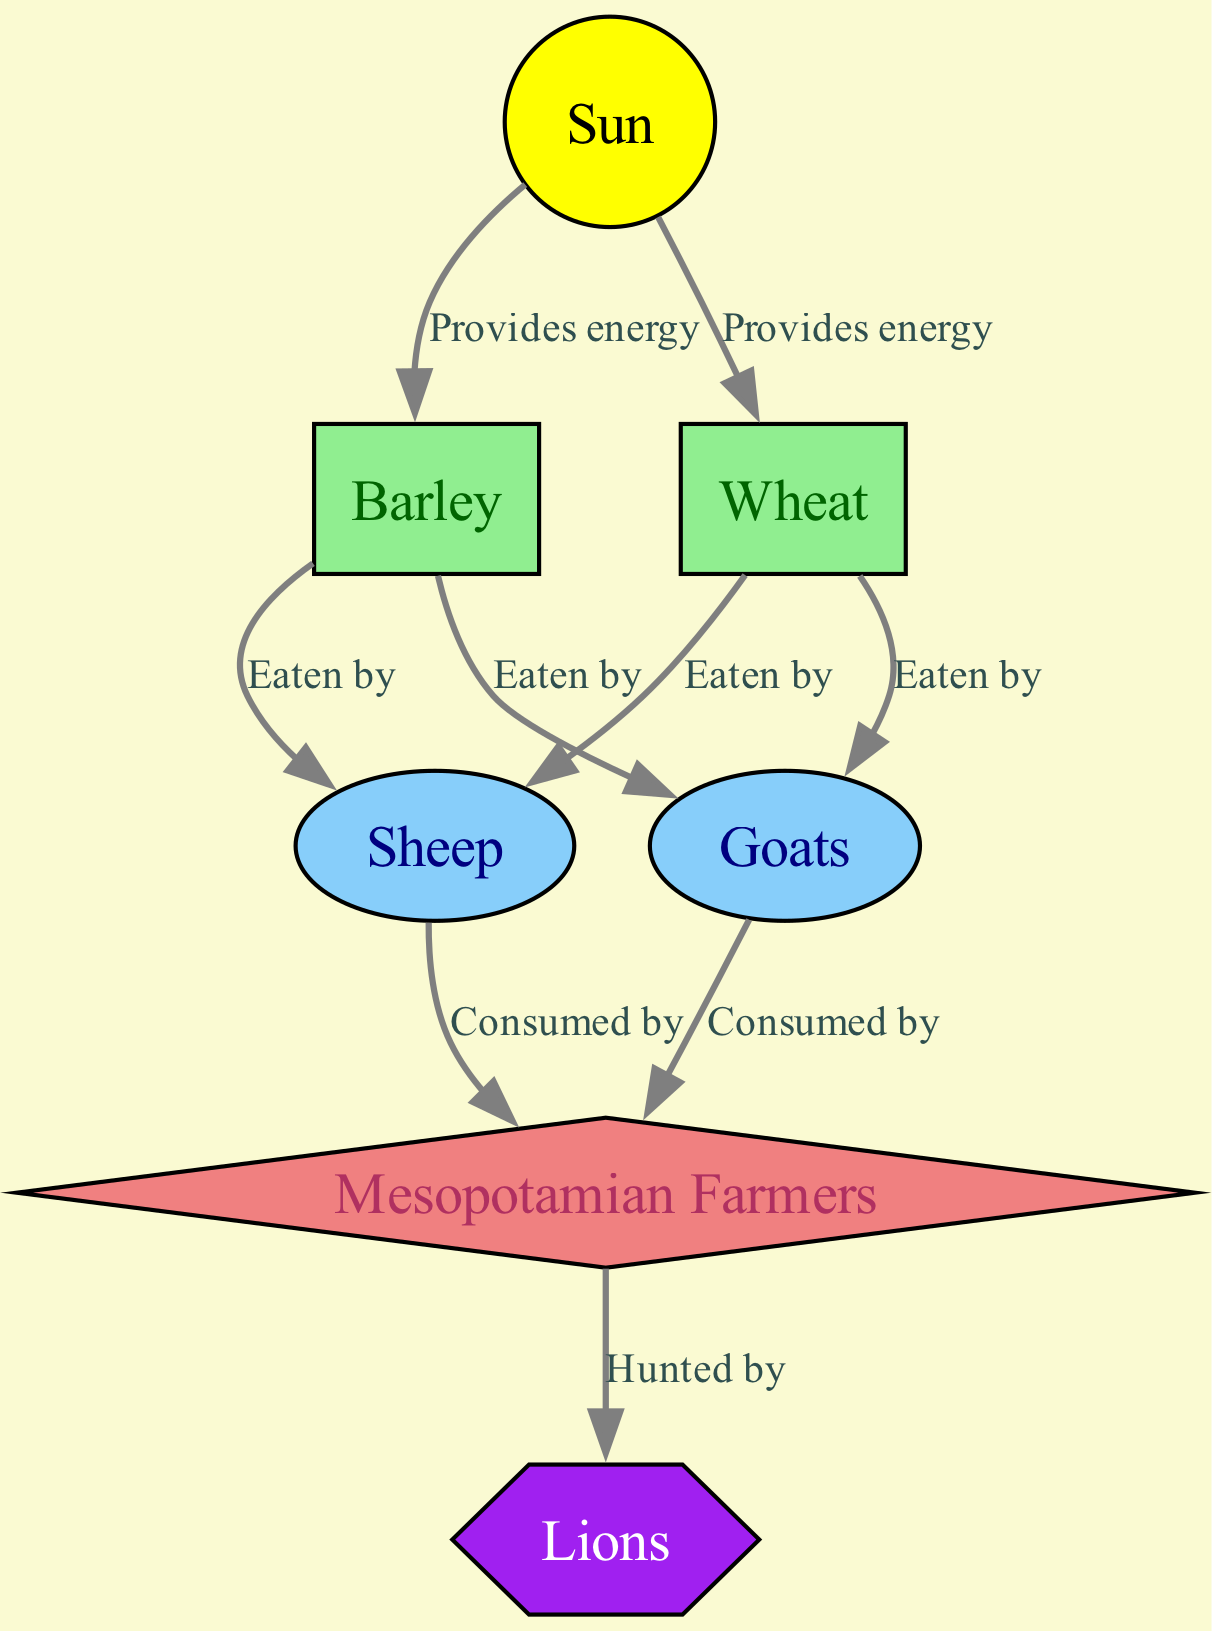What is the primary energy source in this food chain? The diagram begins with the "Sun," which is identified as the energy source for the entire food chain. Thus, the answer to the question is simply the name of that node.
Answer: Sun How many producers are represented in the diagram? The diagram includes two producers: "Barley" and "Wheat." By counting the number of nodes of the type "Producer," we find there are two.
Answer: 2 Who are the primary consumers in this food chain? The primary consumers in the diagram are "Sheep" and "Goats." We can identify these nodes based on their classification as "Primary Consumer."
Answer: Sheep, Goats What type of consumer are Mesopotamian farmers considered in this food chain? The "Mesopotamian Farmers" node is categorized as a "Secondary Consumer." This classification can be directly inferred from the node's labeling in the diagram.
Answer: Secondary Consumer Which producers are eaten by both primary consumers? Both "Barley" and "Wheat" are eaten by "Sheep" and "Goats." Looking through the edges connecting these nodes shows that both producers lead to both primary consumers.
Answer: Barley, Wheat Between primary consumers and the secondary consumer, who consumes whom? The "Sheep" and "Goats" (primary consumers) are both consumed by "Mesopotamian Farmers" (secondary consumer). By checking the directional edges, it is clear who consumes whom in the food chain.
Answer: Sheep, Goats What is the relationship between Mesopotamian Farmers and Lions? The "Mesopotamian Farmers" are hunted by "Lions." This relationship is depicted in the diagram with a directed edge from the secondary consumer to the tertiary consumer labeled "Hunted by."
Answer: Hunted by How many total nodes are present in the food chain? By counting each node listed in the diagram, there are a total of seven nodes. This includes energy source, producers, consumers, and end consumers.
Answer: 7 Which node is the highest level in the food chain? The highest level in the food chain is represented by "Lions," which are categorized as tertiary consumers. Thus, they are at the top of this food chain in terms of predation.
Answer: Lions 